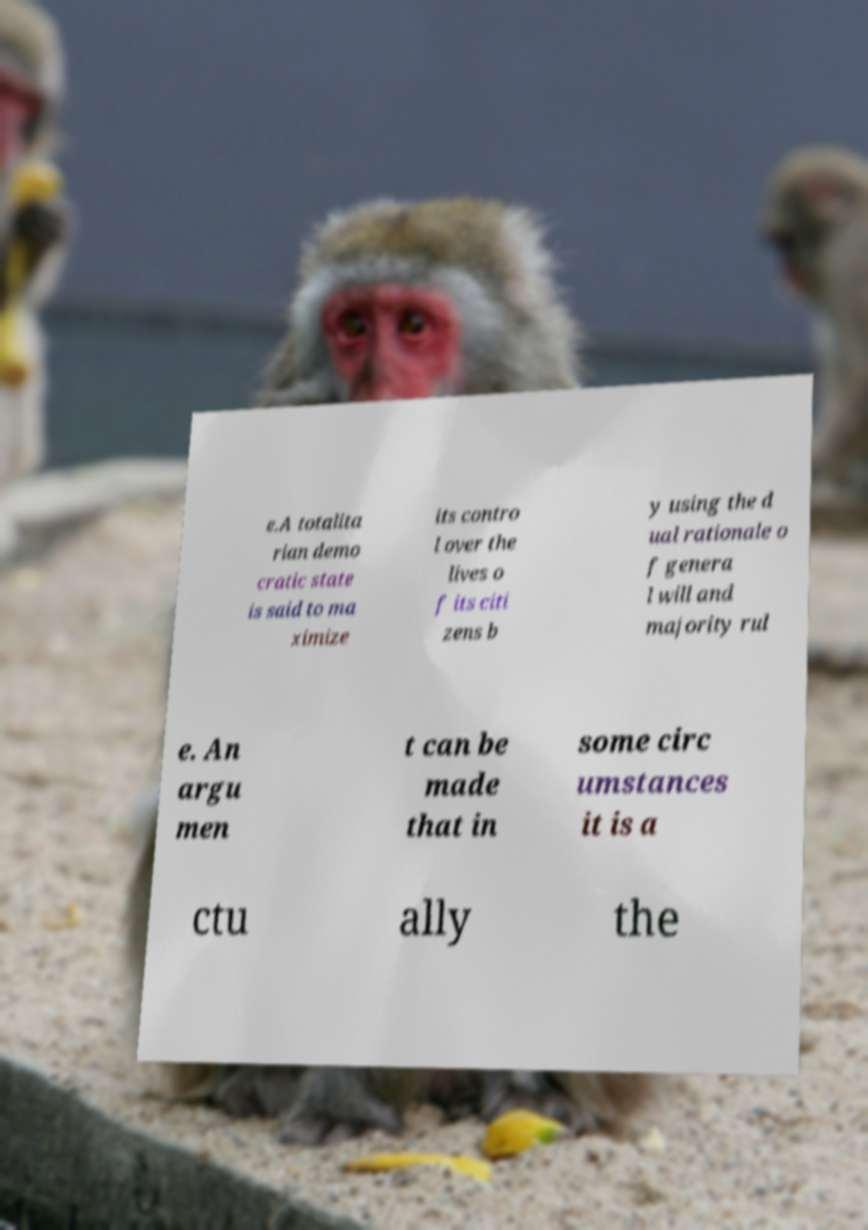For documentation purposes, I need the text within this image transcribed. Could you provide that? e.A totalita rian demo cratic state is said to ma ximize its contro l over the lives o f its citi zens b y using the d ual rationale o f genera l will and majority rul e. An argu men t can be made that in some circ umstances it is a ctu ally the 